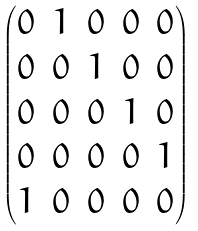<formula> <loc_0><loc_0><loc_500><loc_500>\begin{pmatrix} 0 & 1 & 0 & 0 & 0 \\ 0 & 0 & 1 & 0 & 0 \\ 0 & 0 & 0 & 1 & 0 \\ 0 & 0 & 0 & 0 & 1 \\ 1 & 0 & 0 & 0 & 0 \end{pmatrix}</formula> 